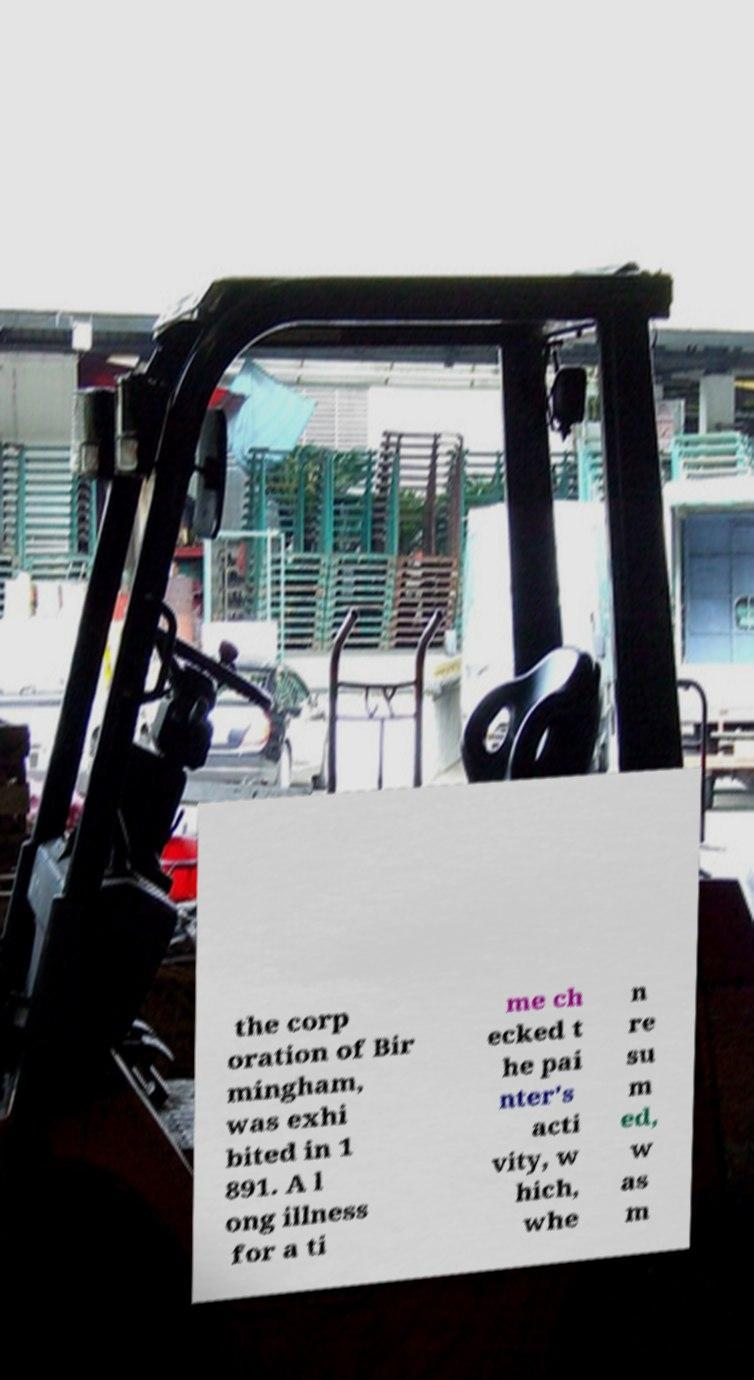What messages or text are displayed in this image? I need them in a readable, typed format. the corp oration of Bir mingham, was exhi bited in 1 891. A l ong illness for a ti me ch ecked t he pai nter's acti vity, w hich, whe n re su m ed, w as m 